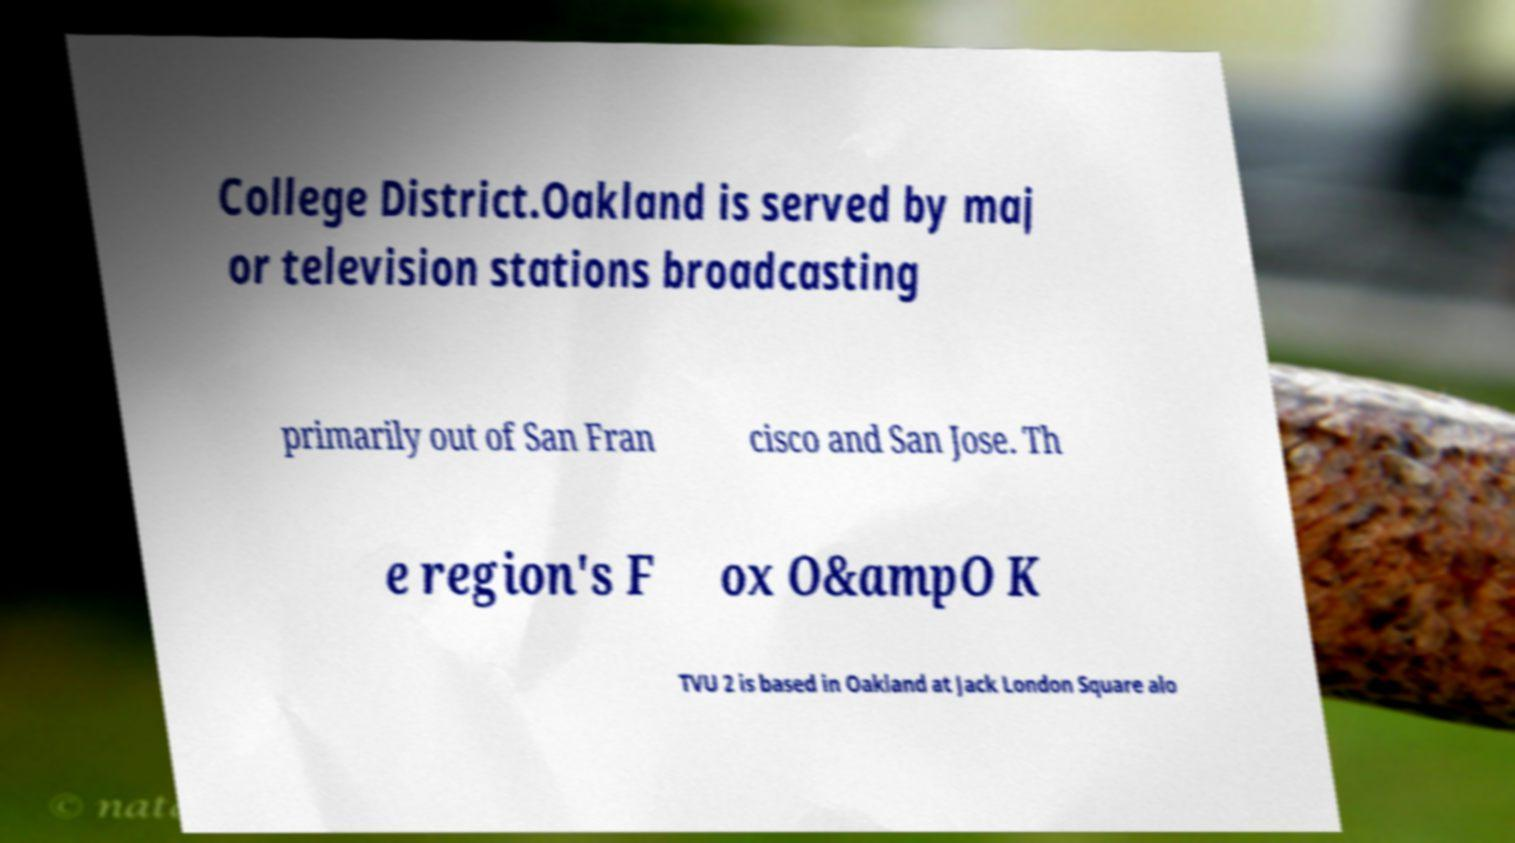There's text embedded in this image that I need extracted. Can you transcribe it verbatim? College District.Oakland is served by maj or television stations broadcasting primarily out of San Fran cisco and San Jose. Th e region's F ox O&ampO K TVU 2 is based in Oakland at Jack London Square alo 